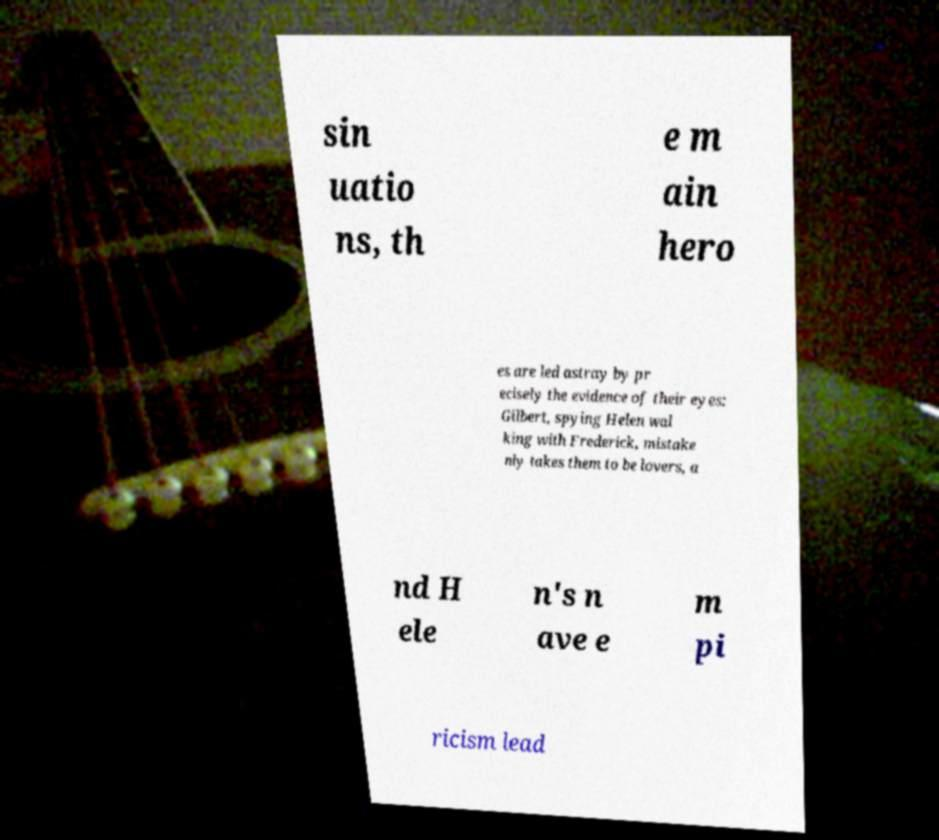I need the written content from this picture converted into text. Can you do that? sin uatio ns, th e m ain hero es are led astray by pr ecisely the evidence of their eyes: Gilbert, spying Helen wal king with Frederick, mistake nly takes them to be lovers, a nd H ele n's n ave e m pi ricism lead 